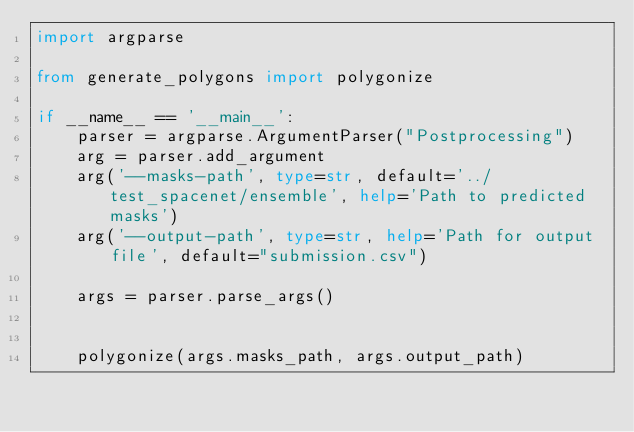<code> <loc_0><loc_0><loc_500><loc_500><_Python_>import argparse

from generate_polygons import polygonize

if __name__ == '__main__':
    parser = argparse.ArgumentParser("Postprocessing")
    arg = parser.add_argument
    arg('--masks-path', type=str, default='../test_spacenet/ensemble', help='Path to predicted masks')
    arg('--output-path', type=str, help='Path for output file', default="submission.csv")

    args = parser.parse_args()


    polygonize(args.masks_path, args.output_path)
</code> 